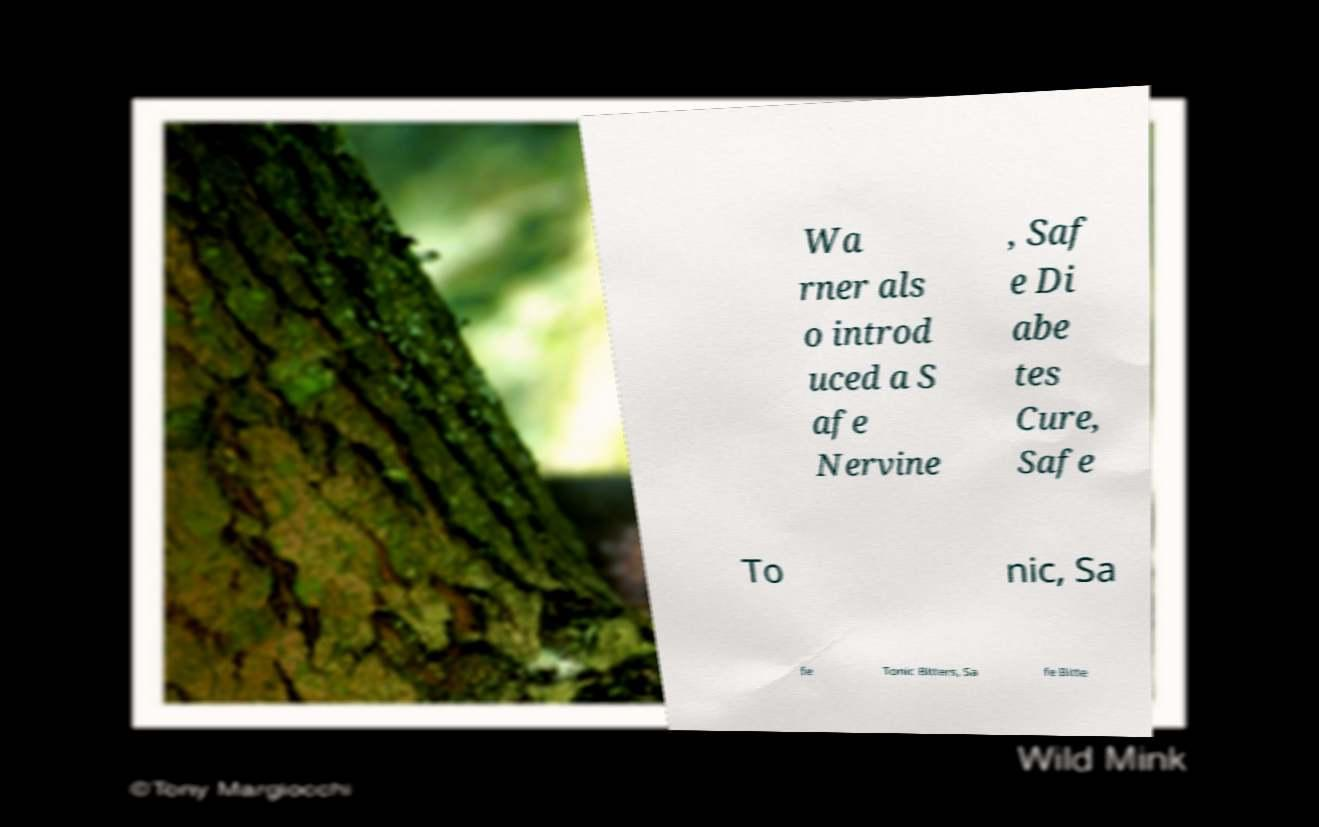I need the written content from this picture converted into text. Can you do that? Wa rner als o introd uced a S afe Nervine , Saf e Di abe tes Cure, Safe To nic, Sa fe Tonic Bitters, Sa fe Bitte 